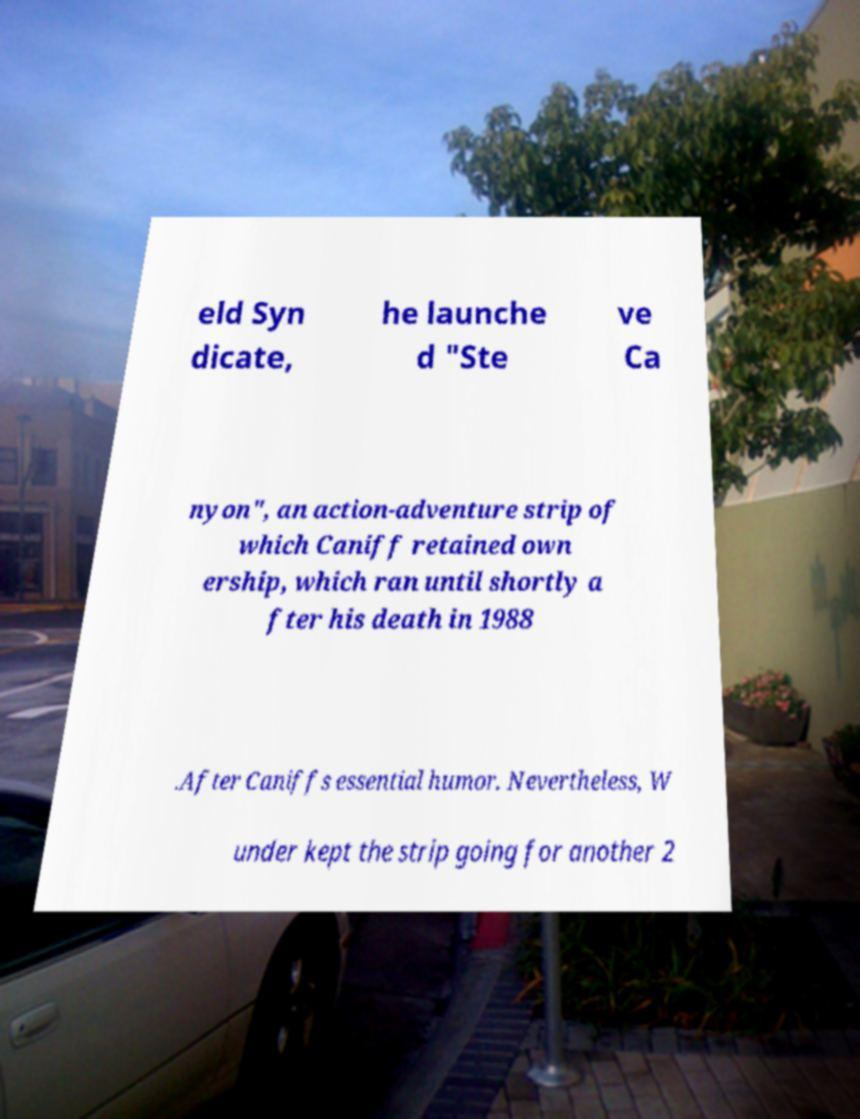Could you extract and type out the text from this image? eld Syn dicate, he launche d "Ste ve Ca nyon", an action-adventure strip of which Caniff retained own ership, which ran until shortly a fter his death in 1988 .After Caniffs essential humor. Nevertheless, W under kept the strip going for another 2 